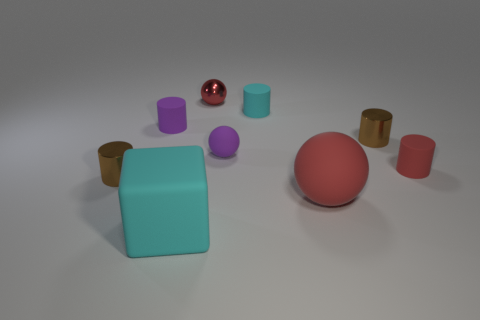Which objects seem to be the largest? The largest objects in the image are the turquoise block at the center front and the red sphere to its right. Their size dominates the rest of the items in the scene. How do the colors of the objects contribute to the composition of the image? The image features a mix of warm and cool colors that are balanced throughout the composition. The cool turquoise and purple objects contrast with the warm gold and red shades, creating a visually appealing palette that adds depth and interest to the scene. 